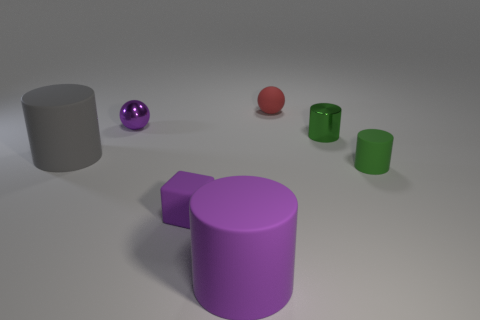Does the object behind the shiny ball have the same color as the matte cylinder on the left side of the small purple ball? no 